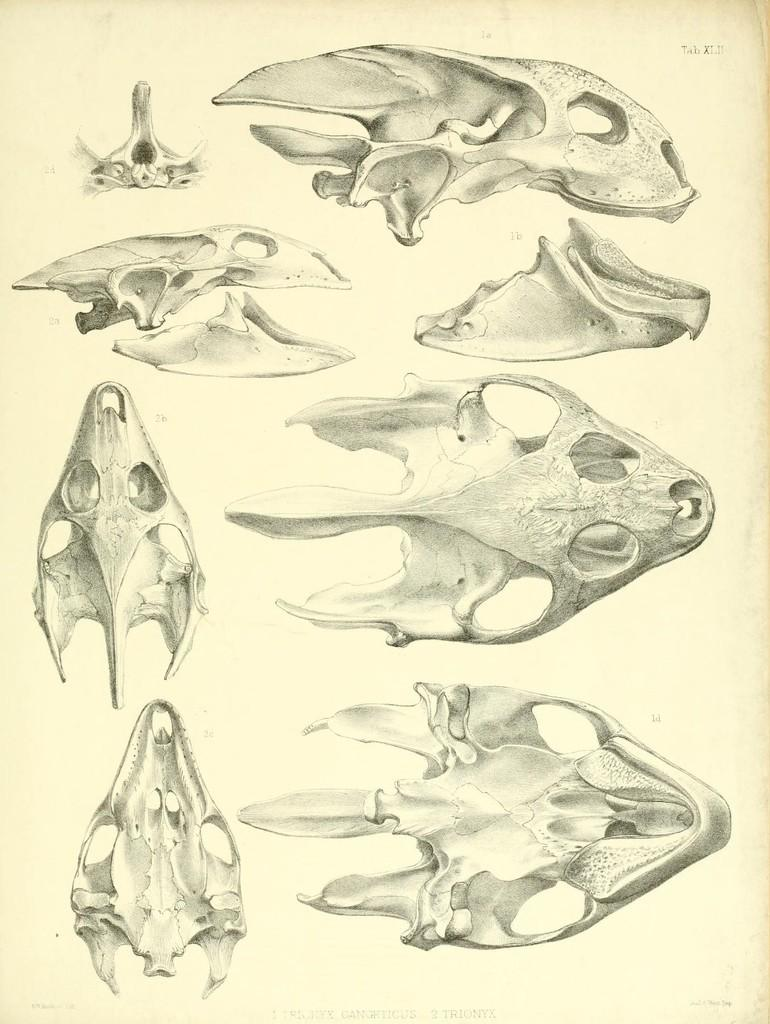What is present in the image? There is a paper in the image. What is depicted on the paper? The paper has a drawing of an animal skull on it. What type of yarn is used to create the drawing on the paper? There is no yarn present in the image; the drawing is made using a pen or pencil, not yarn. 